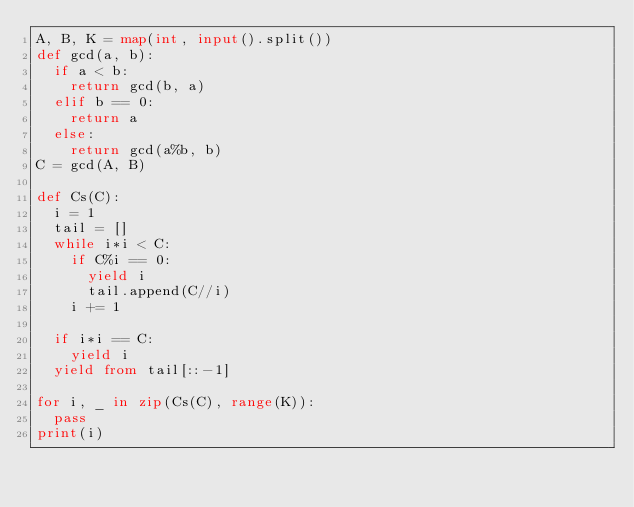Convert code to text. <code><loc_0><loc_0><loc_500><loc_500><_Python_>A, B, K = map(int, input().split())
def gcd(a, b):
  if a < b:
    return gcd(b, a)
  elif b == 0:
    return a
  else:
    return gcd(a%b, b)
C = gcd(A, B)

def Cs(C):
  i = 1
  tail = []
  while i*i < C:
    if C%i == 0:
      yield i
      tail.append(C//i)
    i += 1

  if i*i == C:
    yield i
  yield from tail[::-1]
  
for i, _ in zip(Cs(C), range(K)):
	pass
print(i)</code> 